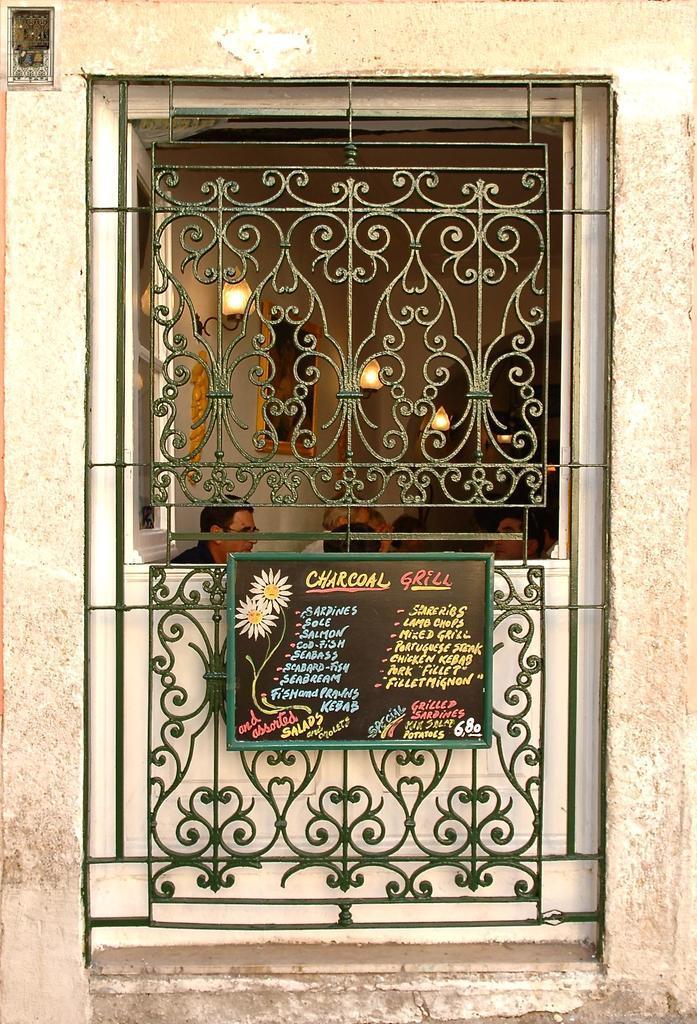Can you describe this image briefly? In the center of the image there is a window with a grill. There is a board with some text on it. In the background of the image there are people, lights. 